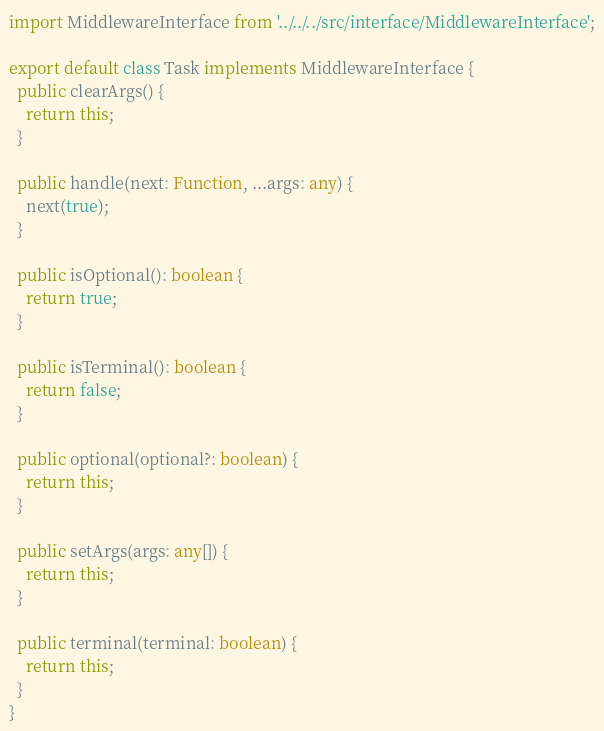<code> <loc_0><loc_0><loc_500><loc_500><_TypeScript_>import MiddlewareInterface from '../../../src/interface/MiddlewareInterface';

export default class Task implements MiddlewareInterface {
  public clearArgs() {
    return this;
  }

  public handle(next: Function, ...args: any) {
    next(true);
  }

  public isOptional(): boolean {
    return true;
  }

  public isTerminal(): boolean {
    return false;
  }

  public optional(optional?: boolean) {
    return this;
  }

  public setArgs(args: any[]) {
    return this;
  }

  public terminal(terminal: boolean) {
    return this;
  }
}
</code> 